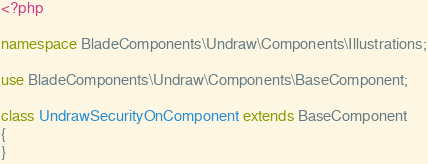<code> <loc_0><loc_0><loc_500><loc_500><_PHP_><?php

namespace BladeComponents\Undraw\Components\Illustrations;

use BladeComponents\Undraw\Components\BaseComponent;

class UndrawSecurityOnComponent extends BaseComponent
{
}
</code> 